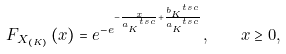Convert formula to latex. <formula><loc_0><loc_0><loc_500><loc_500>F _ { X _ { ( K ) } } \left ( x \right ) = e ^ { - e ^ { - \frac { x } { a ^ { \ t s c } _ { K } } + \frac { b ^ { \ t s c } _ { K } } { a ^ { \ t s c } _ { K } } } } , \quad x \geq 0 ,</formula> 